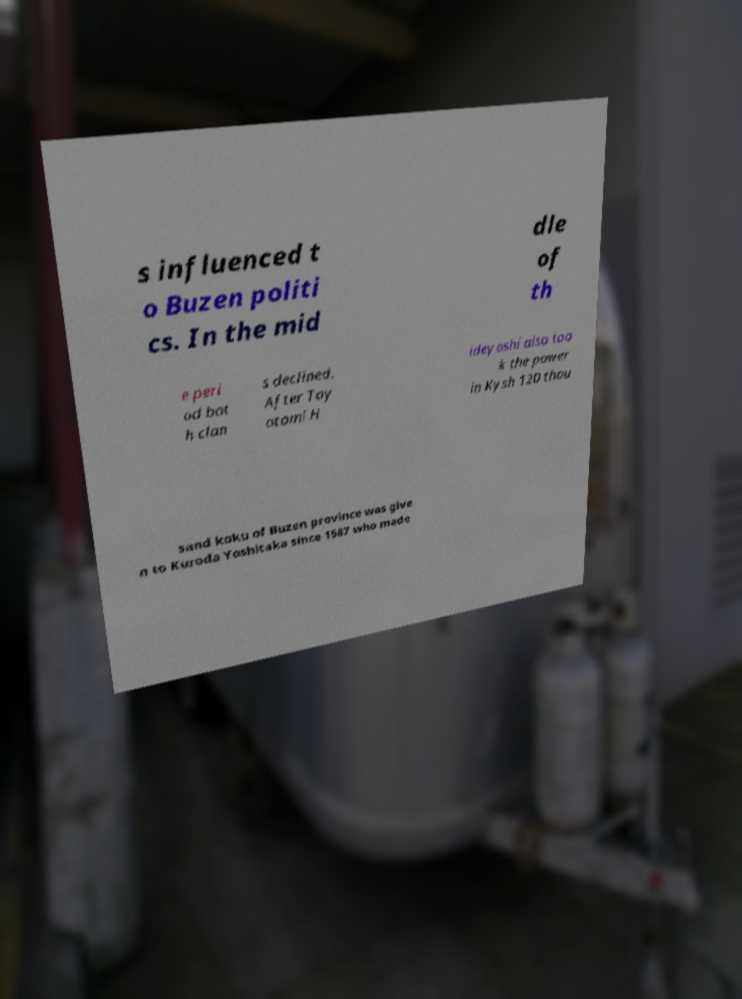I need the written content from this picture converted into text. Can you do that? s influenced t o Buzen politi cs. In the mid dle of th e peri od bot h clan s declined. After Toy otomi H ideyoshi also too k the power in Kysh 120 thou sand koku of Buzen province was give n to Kuroda Yoshitaka since 1587 who made 